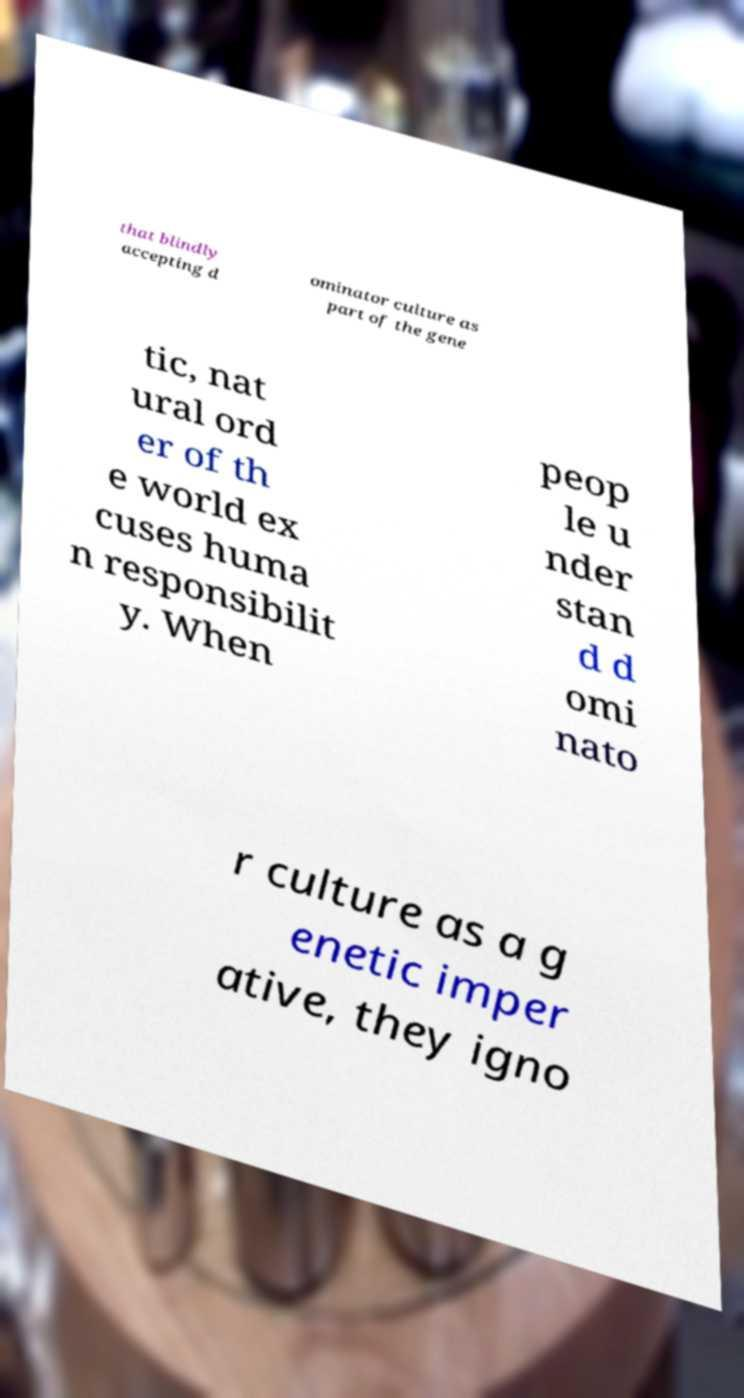Please read and relay the text visible in this image. What does it say? that blindly accepting d ominator culture as part of the gene tic, nat ural ord er of th e world ex cuses huma n responsibilit y. When peop le u nder stan d d omi nato r culture as a g enetic imper ative, they igno 